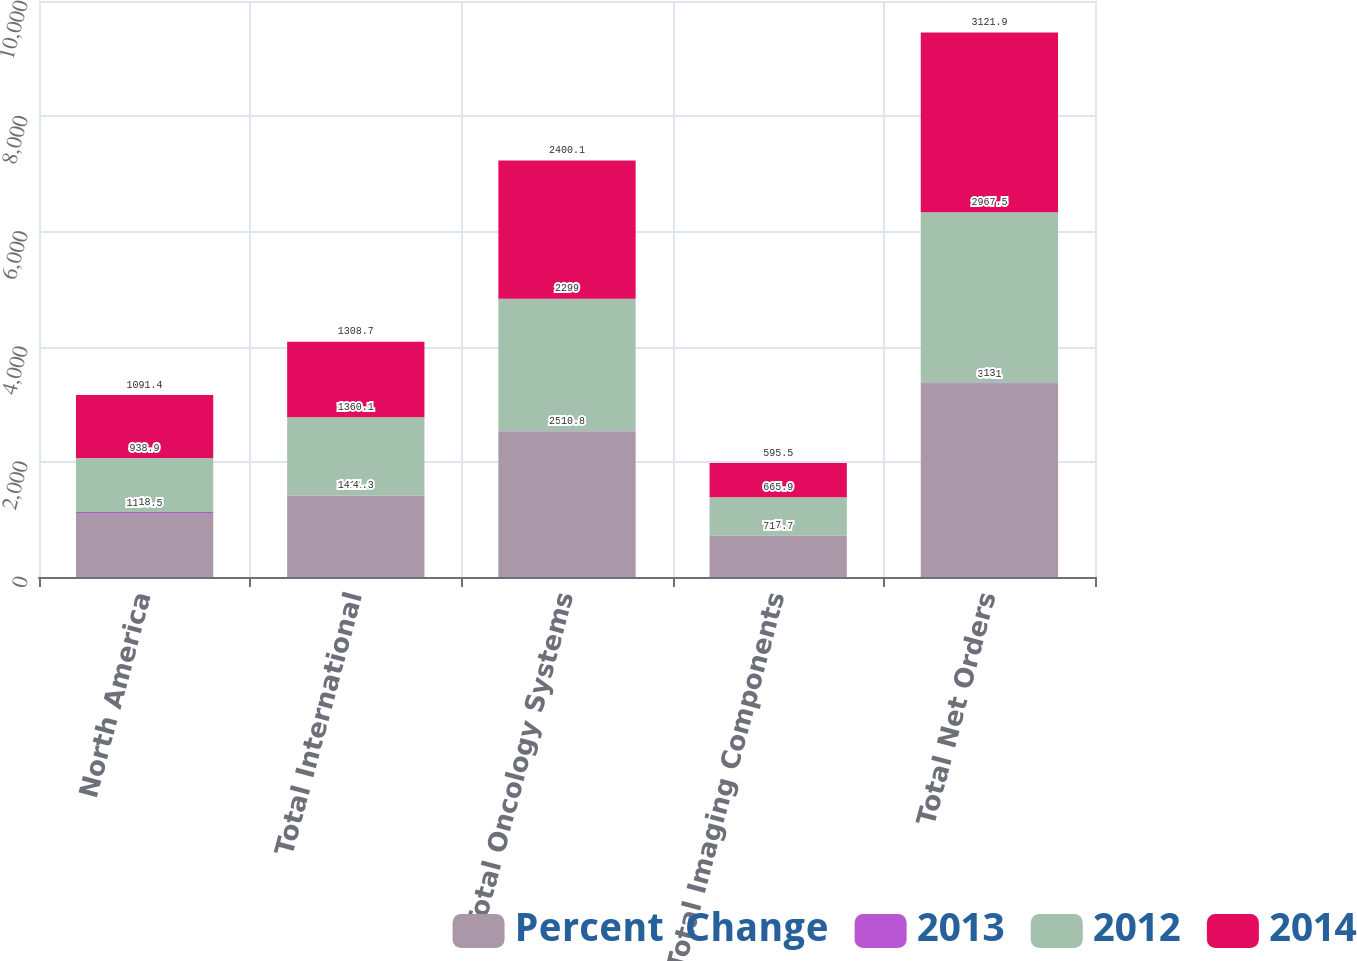Convert chart to OTSL. <chart><loc_0><loc_0><loc_500><loc_500><stacked_bar_chart><ecel><fcel>North America<fcel>Total International<fcel>Total Oncology Systems<fcel>Total Imaging Components<fcel>Total Net Orders<nl><fcel>Percent  Change<fcel>1109.5<fcel>1411.3<fcel>2520.8<fcel>710.7<fcel>3351<nl><fcel>2013<fcel>18<fcel>4<fcel>10<fcel>7<fcel>13<nl><fcel>2012<fcel>938.9<fcel>1360.1<fcel>2299<fcel>665.9<fcel>2967.5<nl><fcel>2014<fcel>1091.4<fcel>1308.7<fcel>2400.1<fcel>595.5<fcel>3121.9<nl></chart> 